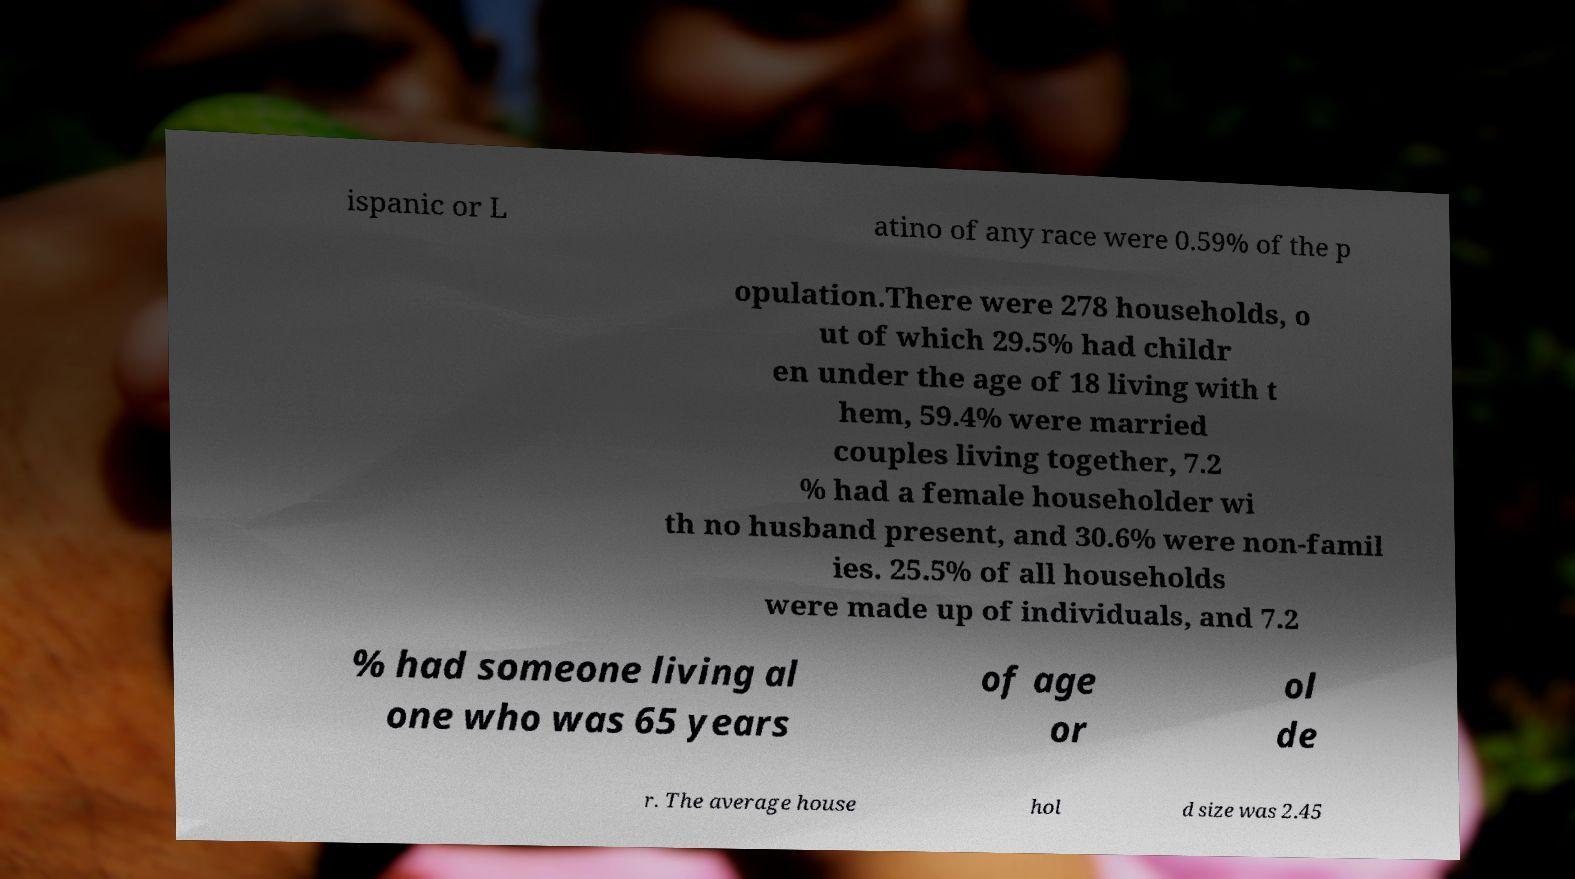Could you extract and type out the text from this image? ispanic or L atino of any race were 0.59% of the p opulation.There were 278 households, o ut of which 29.5% had childr en under the age of 18 living with t hem, 59.4% were married couples living together, 7.2 % had a female householder wi th no husband present, and 30.6% were non-famil ies. 25.5% of all households were made up of individuals, and 7.2 % had someone living al one who was 65 years of age or ol de r. The average house hol d size was 2.45 